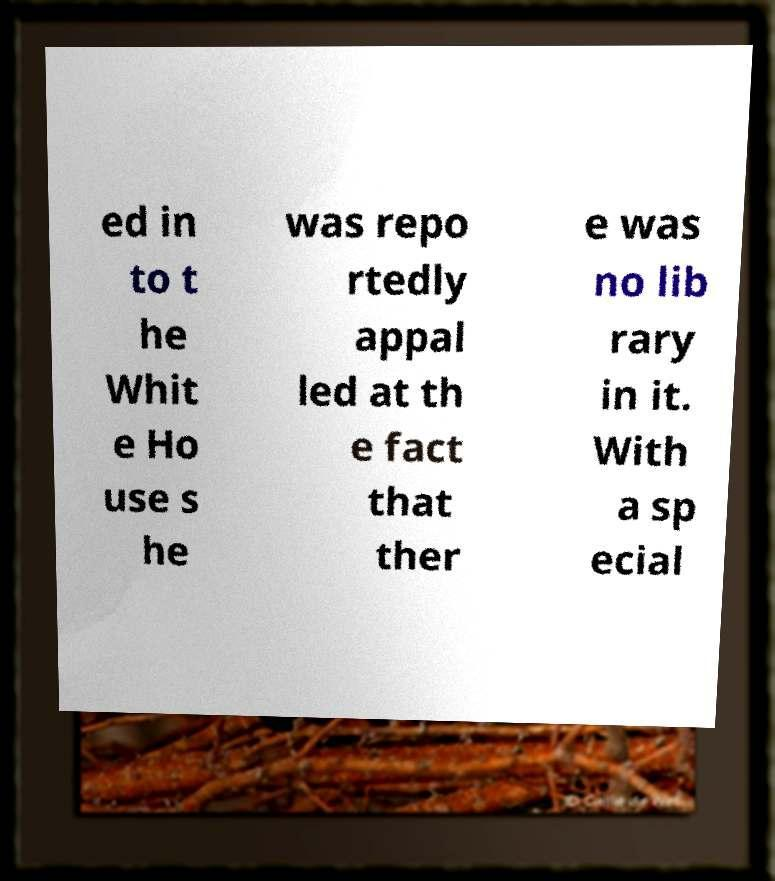Please read and relay the text visible in this image. What does it say? ed in to t he Whit e Ho use s he was repo rtedly appal led at th e fact that ther e was no lib rary in it. With a sp ecial 